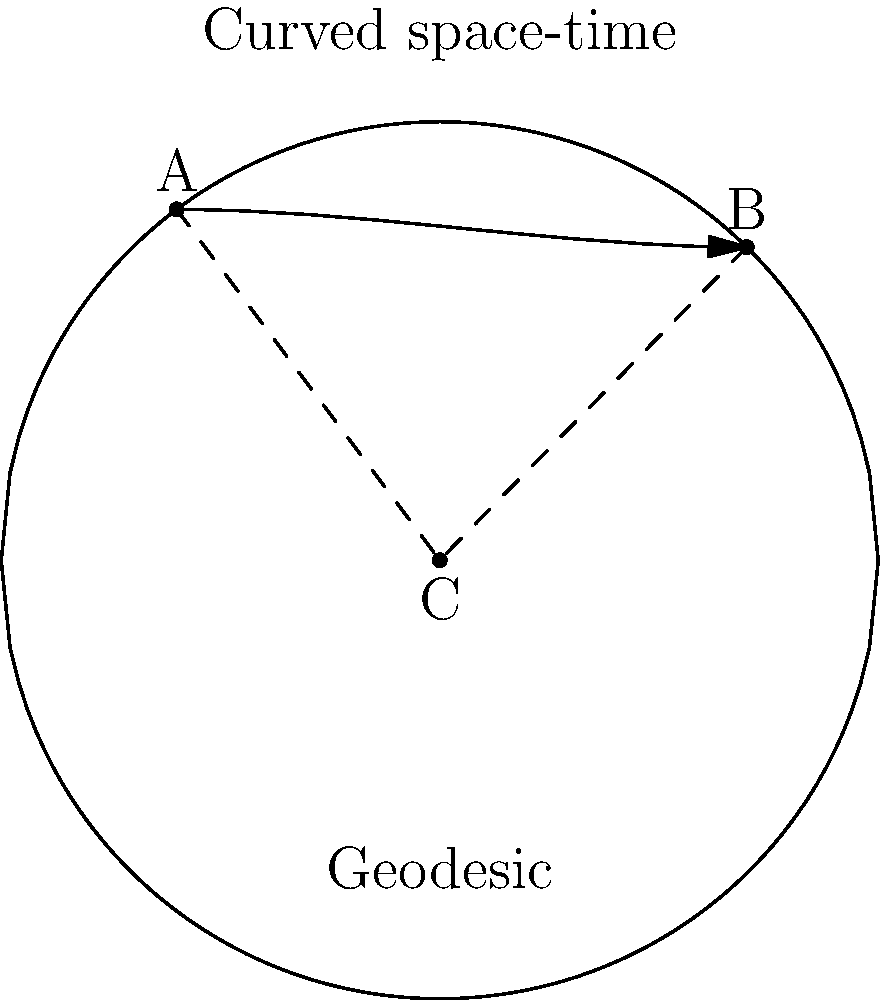In a criminal investigation involving relativistic effects, you need to reconstruct a timeline of events occurring in curved space-time. Given a 2D representation of curved space-time as shown in the diagram, where points A and B represent two events, and the dashed lines represent the apparent straight-line path, what is the most accurate method to measure the true distance between these events for forensic reconstruction? To accurately measure the distance between two events in curved space-time for forensic timeline reconstruction, we need to consider the following steps:

1. Recognize that in curved space-time, the shortest path between two points is not a straight line, but a geodesic.

2. Observe that the curved line in the diagram represents the curvature of space-time, and the arrow indicates the geodesic path between points A and B.

3. Understand that the geodesic represents the path that light or a free-falling object would follow in this curved space-time.

4. Realize that the proper distance along this geodesic is the most accurate measure of the "distance" between the two events in space-time.

5. To calculate this distance, we would need to use the metric tensor of the curved space-time and integrate along the geodesic path:

   $$s = \int_{A}^{B} \sqrt{g_{\mu\nu}dx^{\mu}dx^{\nu}}$$

   where $g_{\mu\nu}$ is the metric tensor and $dx^{\mu}$ are the coordinate differentials along the path.

6. In practice, this often requires numerical integration techniques, as analytical solutions may not be available for complex space-time geometries.

7. For forensic reconstruction, this geodesic distance would provide the most accurate representation of the space-time interval between the events, accounting for relativistic effects due to the curvature of space-time.

Therefore, the most accurate method to measure the true distance between these events is to calculate the length of the geodesic connecting them, rather than using the apparent straight-line distance.
Answer: Calculate the length of the geodesic path 